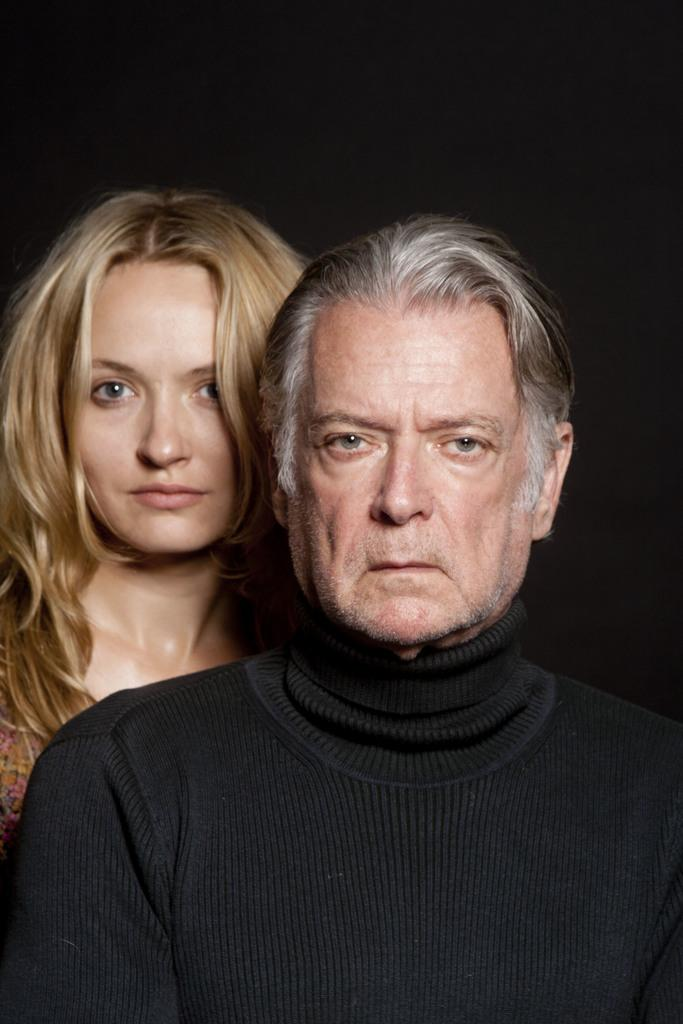How many people are present in the image? There are two people, a man and a woman, present in the image. What is the lighting condition in the background of the image? The background of the image has a dark view. What type of skirt is the woman wearing in the image? There is no skirt visible in the image, as the woman is not wearing one. How many spiders can be seen crawling on the man in the image? There are no spiders present in the image; it only features a man and a woman. 